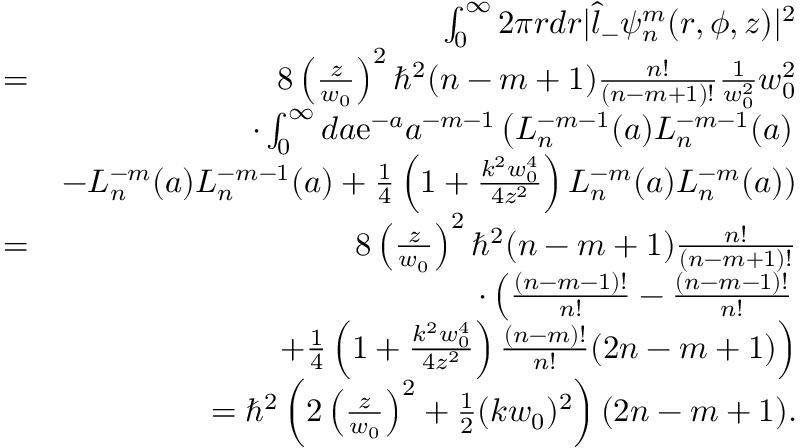Convert formula to latex. <formula><loc_0><loc_0><loc_500><loc_500>\begin{array} { r l r } & { \int _ { 0 } ^ { \infty } 2 \pi r d r | \hat { l } _ { - } \psi _ { n } ^ { m } ( r , \phi , z ) | ^ { 2 } } \\ & { = } & { 8 \left ( \frac { z } { w _ { 0 } } \right ) ^ { 2 } \hbar { ^ } { 2 } ( n - m + 1 ) \frac { n ! } { ( n - m + 1 ) ! } \frac { 1 } { w _ { 0 } ^ { 2 } } w _ { 0 } ^ { 2 } } \\ & { \cdot \int _ { 0 } ^ { \infty } d a e ^ { - a } a ^ { - m - 1 } \left ( L _ { n } ^ { - m - 1 } ( a ) L _ { n } ^ { - m - 1 } ( a ) } \\ & { - L _ { n } ^ { - m } ( a ) L _ { n } ^ { - m - 1 } ( a ) + \frac { 1 } { 4 } \left ( 1 + \frac { k ^ { 2 } w _ { 0 } ^ { 4 } } { 4 z ^ { 2 } } \right ) L _ { n } ^ { - m } ( a ) L _ { n } ^ { - m } ( a ) ) } \\ & { = } & { 8 \left ( \frac { z } { w _ { 0 } } \right ) ^ { 2 } \hbar { ^ } { 2 } ( n - m + 1 ) \frac { n ! } { ( n - m + 1 ) ! } } \\ & { \cdot \left ( \frac { ( n - m - 1 ) ! } { n ! } - \frac { ( n - m - 1 ) ! } { n ! } } \\ & { + \frac { 1 } { 4 } \left ( 1 + \frac { k ^ { 2 } w _ { 0 } ^ { 4 } } { 4 z ^ { 2 } } \right ) \frac { ( n - m ) ! } { n ! } ( 2 n - m + 1 ) \right ) } \\ & { = \hbar { ^ } { 2 } \left ( 2 \left ( \frac { z } { w _ { 0 } } \right ) ^ { 2 } + \frac { 1 } { 2 } ( k w _ { 0 } ) ^ { 2 } \right ) ( 2 n - m + 1 ) . } \end{array}</formula> 